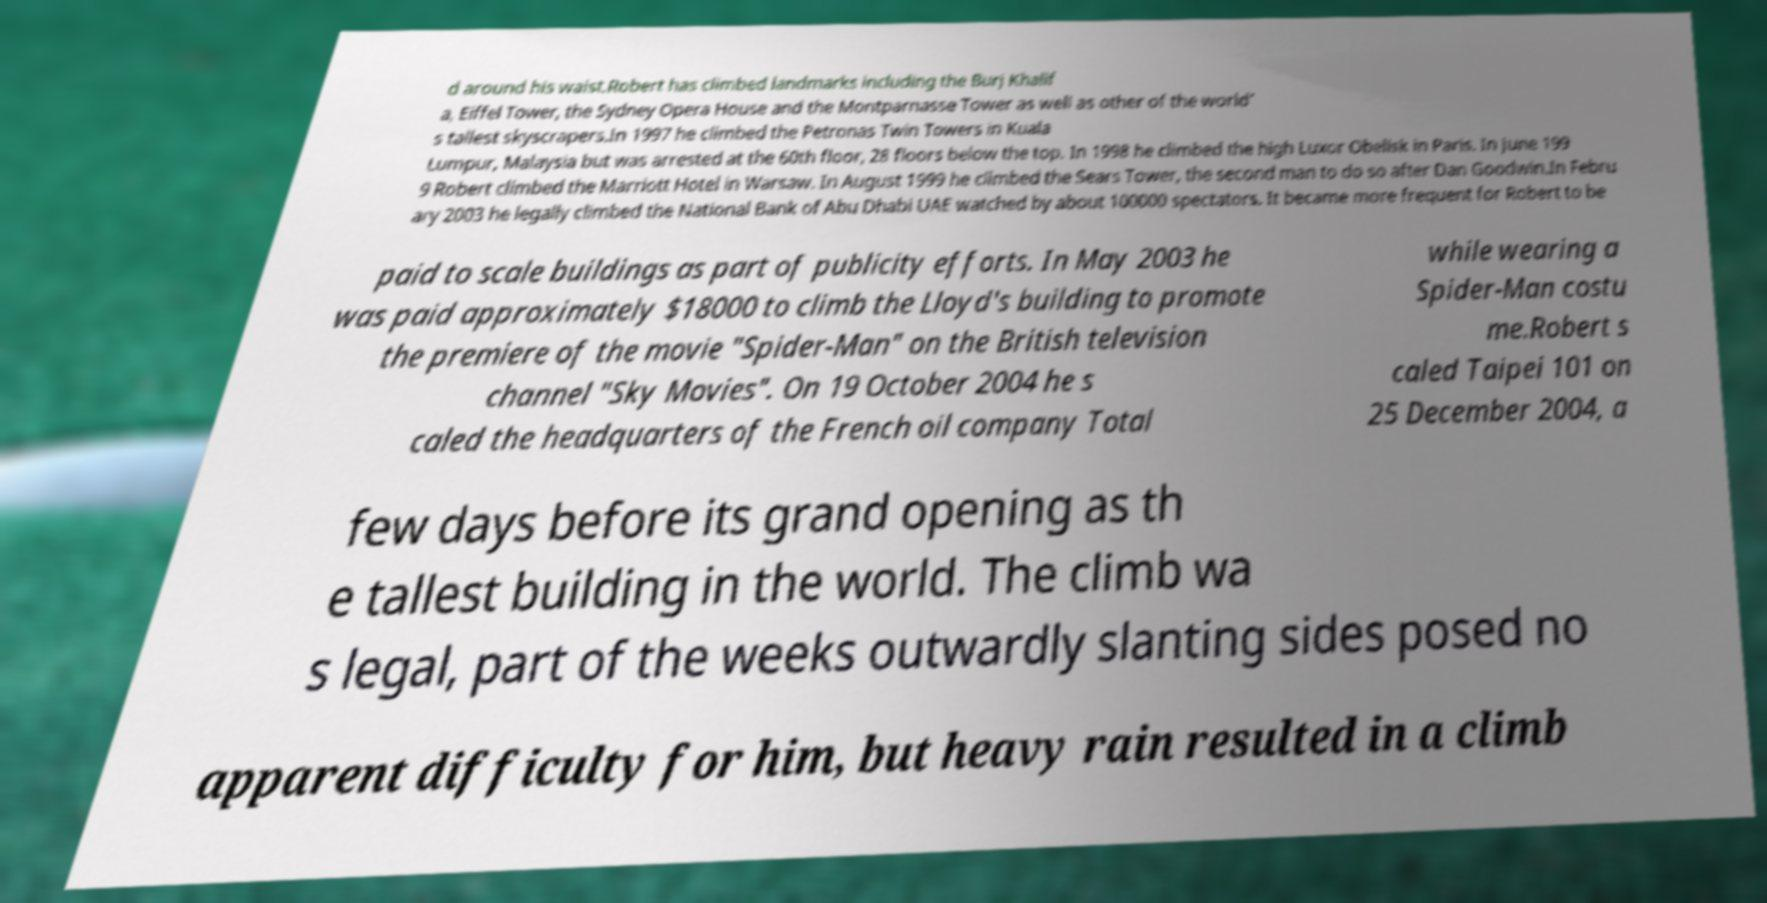For documentation purposes, I need the text within this image transcribed. Could you provide that? d around his waist.Robert has climbed landmarks including the Burj Khalif a, Eiffel Tower, the Sydney Opera House and the Montparnasse Tower as well as other of the world' s tallest skyscrapers.In 1997 he climbed the Petronas Twin Towers in Kuala Lumpur, Malaysia but was arrested at the 60th floor, 28 floors below the top. In 1998 he climbed the high Luxor Obelisk in Paris. In June 199 9 Robert climbed the Marriott Hotel in Warsaw. In August 1999 he climbed the Sears Tower, the second man to do so after Dan Goodwin.In Febru ary 2003 he legally climbed the National Bank of Abu Dhabi UAE watched by about 100000 spectators. It became more frequent for Robert to be paid to scale buildings as part of publicity efforts. In May 2003 he was paid approximately $18000 to climb the Lloyd's building to promote the premiere of the movie "Spider-Man" on the British television channel "Sky Movies". On 19 October 2004 he s caled the headquarters of the French oil company Total while wearing a Spider-Man costu me.Robert s caled Taipei 101 on 25 December 2004, a few days before its grand opening as th e tallest building in the world. The climb wa s legal, part of the weeks outwardly slanting sides posed no apparent difficulty for him, but heavy rain resulted in a climb 